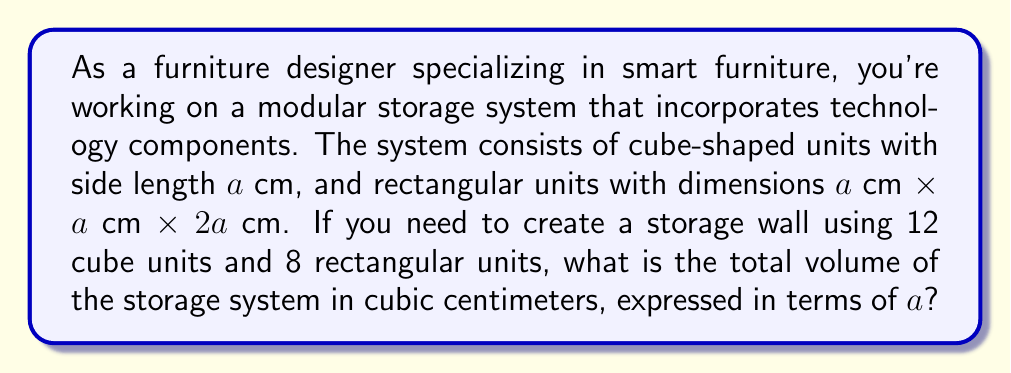Help me with this question. To solve this problem, we need to follow these steps:

1. Calculate the volume of a single cube unit:
   $$V_{cube} = a^3$$

2. Calculate the volume of a single rectangular unit:
   $$V_{rect} = a \times a \times 2a = 2a^3$$

3. Calculate the total volume of all cube units:
   $$V_{total\_cubes} = 12 \times a^3 = 12a^3$$

4. Calculate the total volume of all rectangular units:
   $$V_{total\_rect} = 8 \times 2a^3 = 16a^3$$

5. Sum up the total volume of all units:
   $$V_{total} = V_{total\_cubes} + V_{total\_rect}$$
   $$V_{total} = 12a^3 + 16a^3 = 28a^3$$

Therefore, the total volume of the storage system is $28a^3$ cubic centimeters.
Answer: $28a^3$ cubic centimeters 